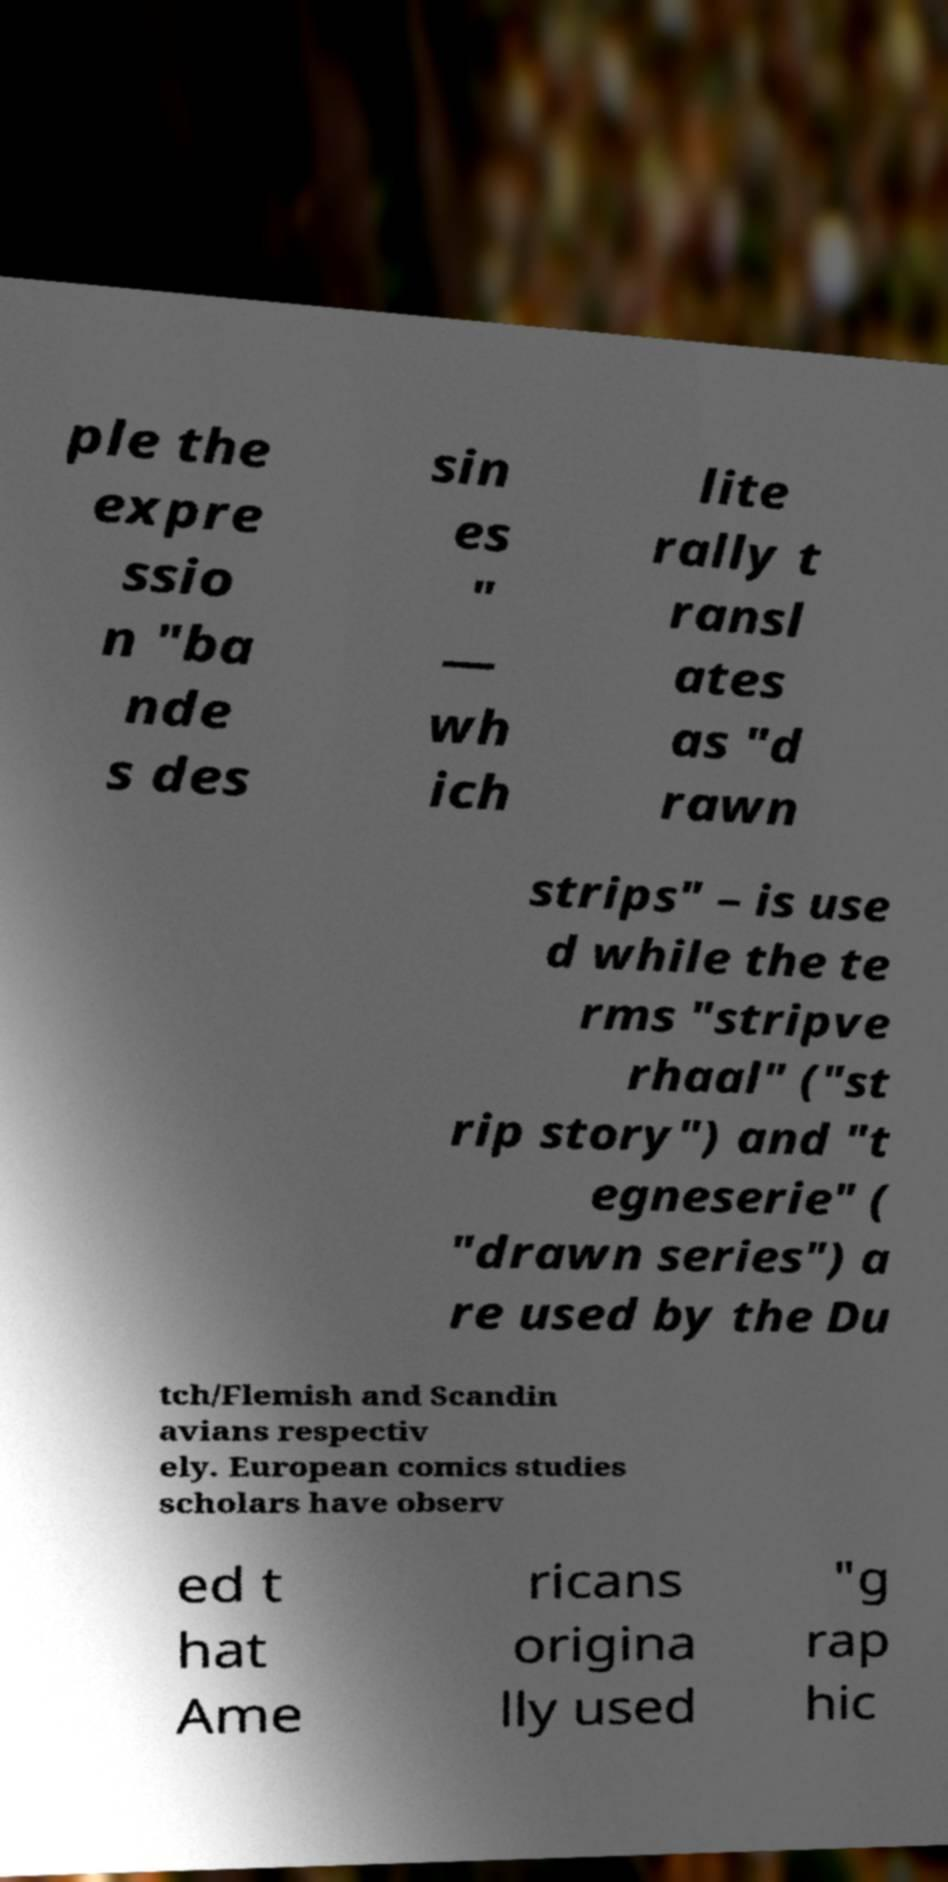What messages or text are displayed in this image? I need them in a readable, typed format. ple the expre ssio n "ba nde s des sin es " — wh ich lite rally t ransl ates as "d rawn strips" – is use d while the te rms "stripve rhaal" ("st rip story") and "t egneserie" ( "drawn series") a re used by the Du tch/Flemish and Scandin avians respectiv ely. European comics studies scholars have observ ed t hat Ame ricans origina lly used "g rap hic 